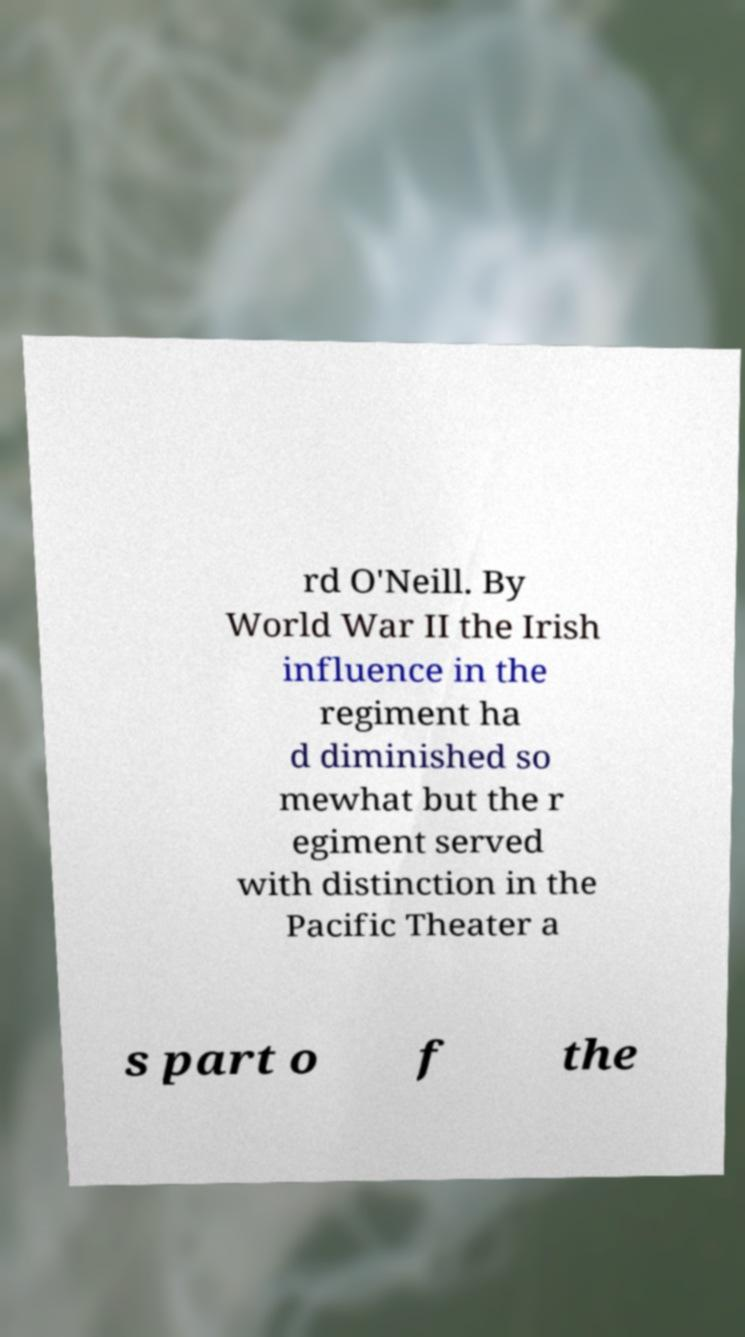Could you assist in decoding the text presented in this image and type it out clearly? rd O'Neill. By World War II the Irish influence in the regiment ha d diminished so mewhat but the r egiment served with distinction in the Pacific Theater a s part o f the 